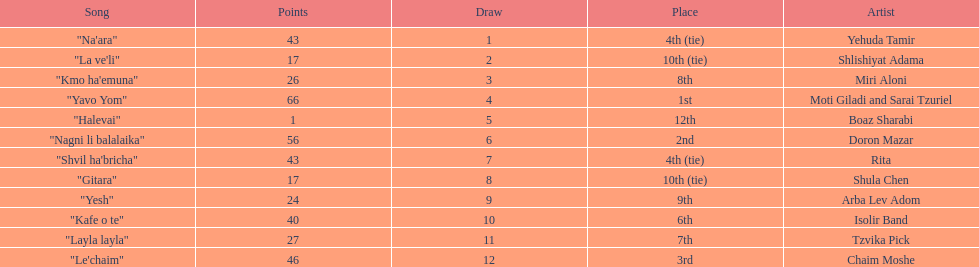Doron mazar, which artist(s) had the most points? Moti Giladi and Sarai Tzuriel. 